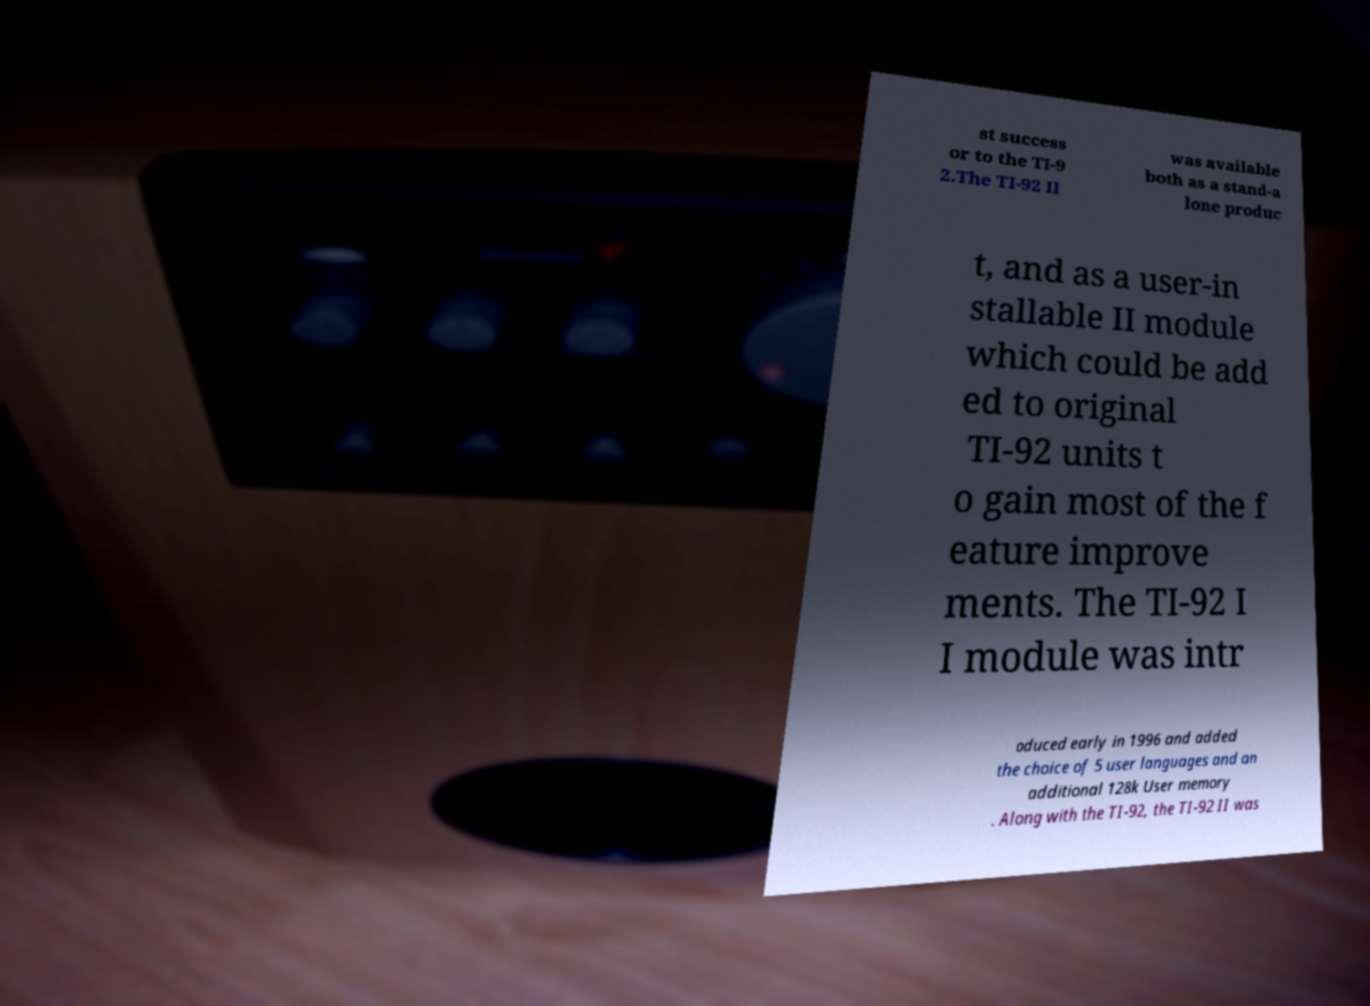Can you accurately transcribe the text from the provided image for me? st success or to the TI-9 2.The TI-92 II was available both as a stand-a lone produc t, and as a user-in stallable II module which could be add ed to original TI-92 units t o gain most of the f eature improve ments. The TI-92 I I module was intr oduced early in 1996 and added the choice of 5 user languages and an additional 128k User memory . Along with the TI-92, the TI-92 II was 